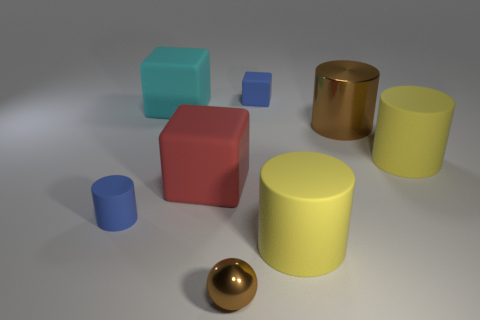Subtract all blue matte blocks. How many blocks are left? 2 Add 2 large blocks. How many objects exist? 10 Subtract all red cubes. How many blue spheres are left? 0 Subtract all large red objects. Subtract all blue cubes. How many objects are left? 6 Add 7 metallic cylinders. How many metallic cylinders are left? 8 Add 3 large brown things. How many large brown things exist? 4 Subtract all cyan cubes. How many cubes are left? 2 Subtract 0 gray cylinders. How many objects are left? 8 Subtract all spheres. How many objects are left? 7 Subtract 3 cylinders. How many cylinders are left? 1 